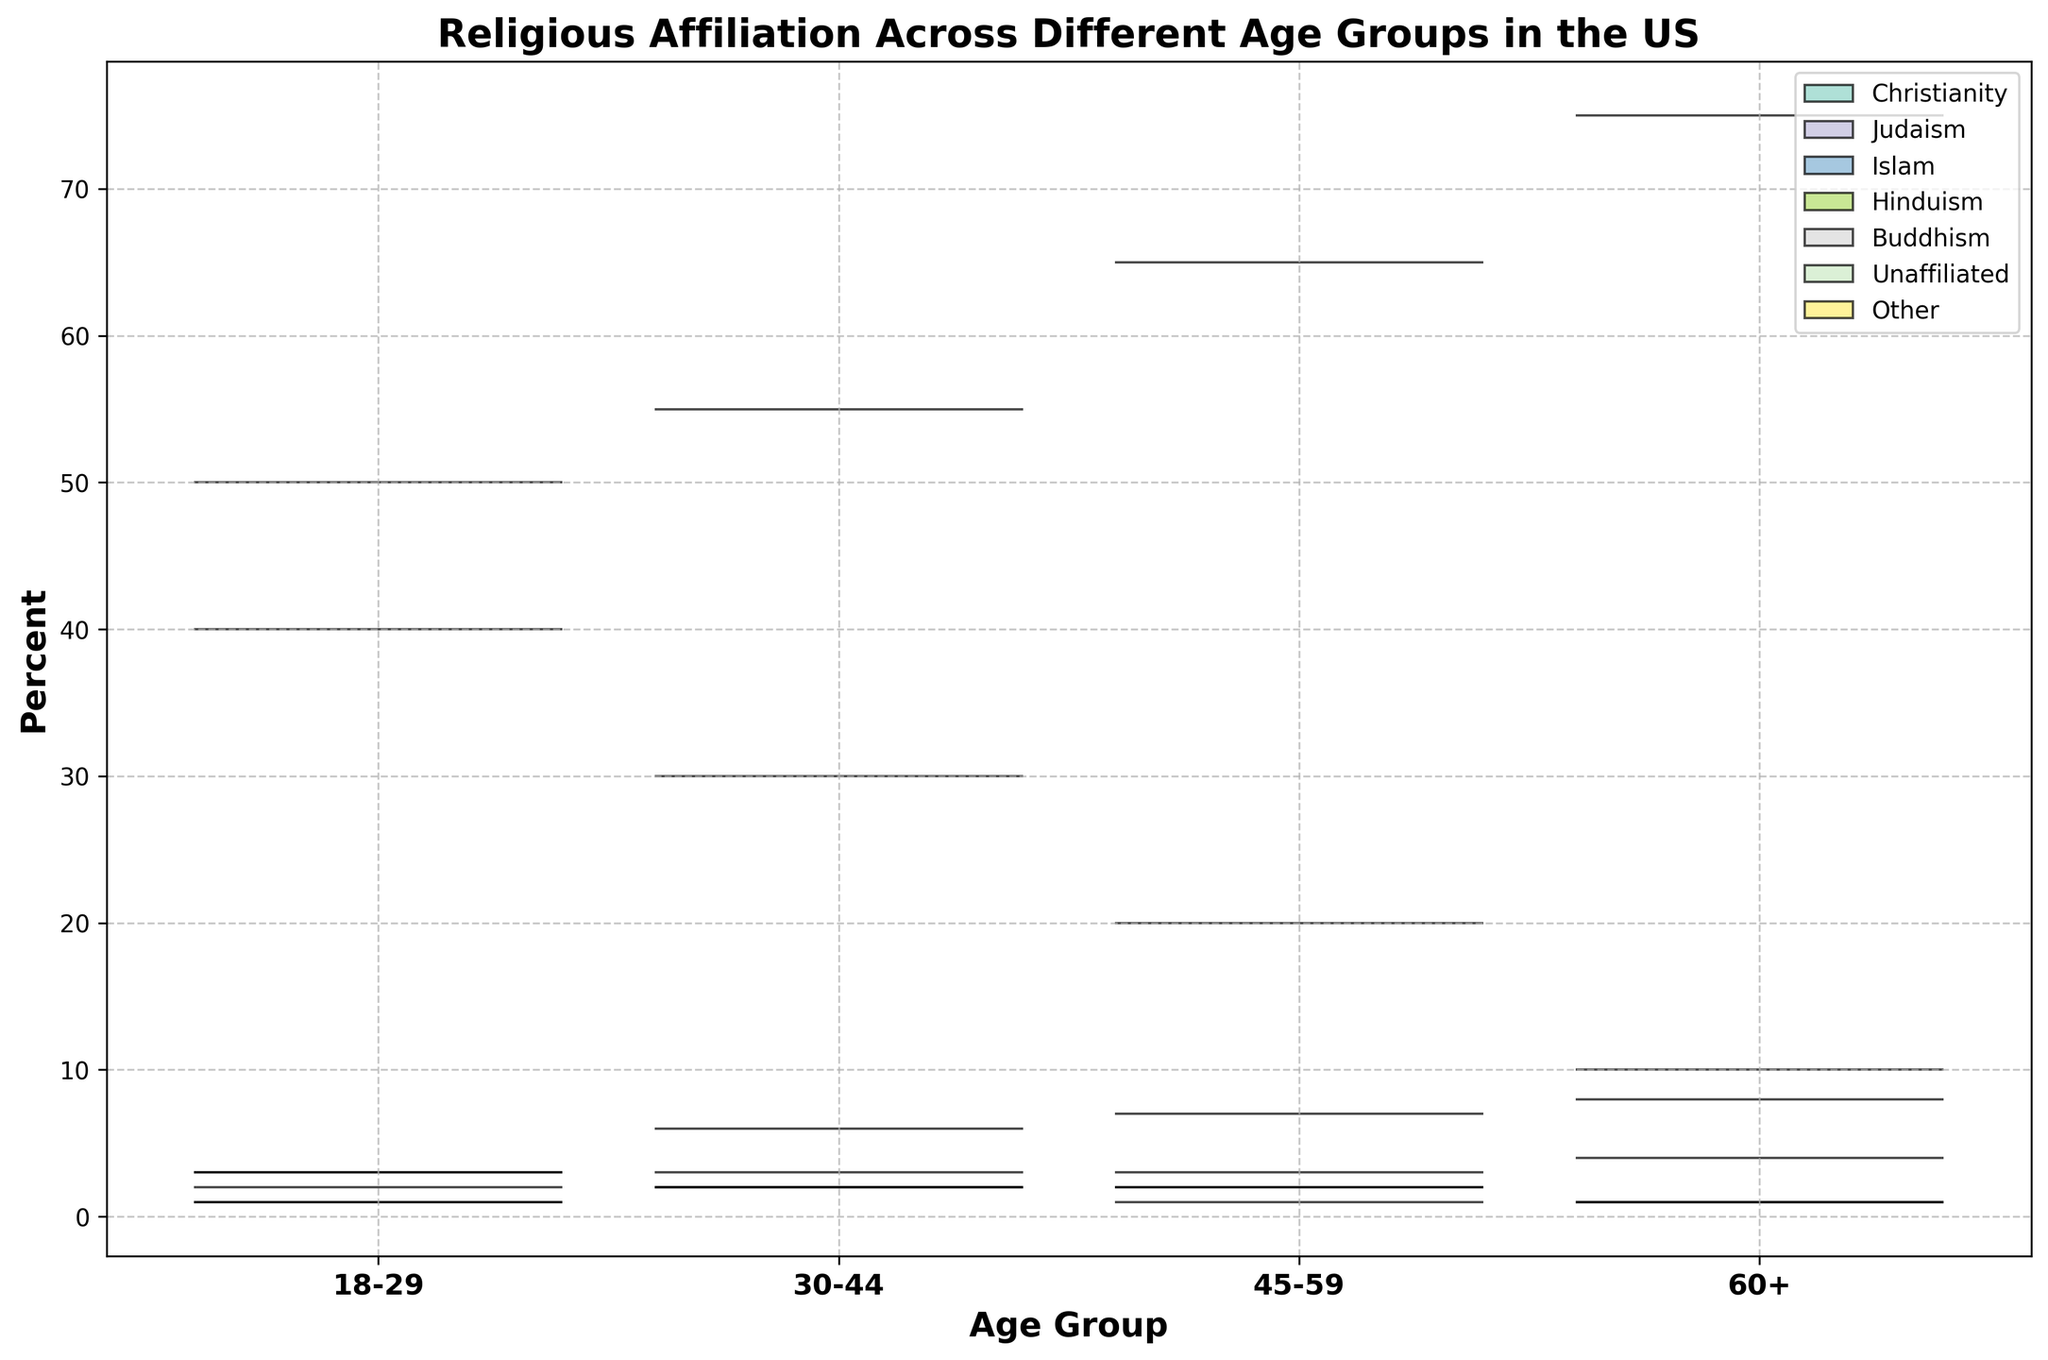What is the title of the figure? The title of the figure is usually displayed at the top of the chart in a larger and bolder font. The title provides a concise summary of what the chart represents. Here, it states, "Religious Affiliation Across Different Age Groups in the US".
Answer: Religious Affiliation Across Different Age Groups in the US What are the age groups represented in the figure? The x-axis of the chart will list the different age groups that are being analyzed. According to the provided data, these are likely displayed as labels on the x-axis ticks.
Answer: 18-29, 30-44, 45-59, 60+ What is the color used to represent Christianity in the violin chart? In the legend of the chart, each religious affiliation is associated with a specific color. By matching the color used for Christianity in the legend, one can identify this color in the chart.
Answer: The specific color is not provided, but it is specified in the legend of the chart Which age group has the highest percentage of unaffiliated individuals? To determine this, locate the violin plot width for "Unaffiliated" across different age groups and identify the one with the widest distribution. This visual cue typically indicates the highest percentage.
Answer: 18-29 What is the difference in the percentage of Christians between the age groups 45-59 and 60+? Look at the violin plots for Christianity in both age groups 45-59 and 60+. By comparing the widths, we can find their respective percentages and subtract one from the other. 75% - 65% gives us the difference.
Answer: 10% How does the percentage of Buddhists change from the youngest to the oldest age group? Track the violin plots for Buddhism across all age groups from 18-29 to 60+. Note the changes, which show a consistent 1% in 18-29, 2% in 30-44, 2% in 45-59, and 1% in 60+, indicating fluctuations.
Answer: It remains nearly constant with slight fluctuations Which religious affiliation shows the least variation across age groups? By comparing the widths and spread of the violin plots for all religions, one can observe which one remains relatively stable. The narrowest and least spread out plots indicate lesser variation.
Answer: Judaism Compare the percentage of Jewish individuals between the age groups 18-29 and 60+. Locate and compare the violin plots for Judaism at these two age groups. The respective percentages are 3% for 18-29 and 4% for 60+.
Answer: 60+ has a 1% higher percentage than 18-29 Which age group shows the highest diversity in religious affiliation? Evaluate the range and spread of the violin plots for each age group. The age group with varied and multiple wide plots indicates higher diversity in religious affiliation.
Answer: 60+ What percentage of the 30-44 age group is unaffiliated? Directly observe the width and position of the violin plot labeled "Unaffiliated" for the 30-44 age group. This visual cue points to a percentage.
Answer: 30% 